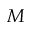<formula> <loc_0><loc_0><loc_500><loc_500>M</formula> 